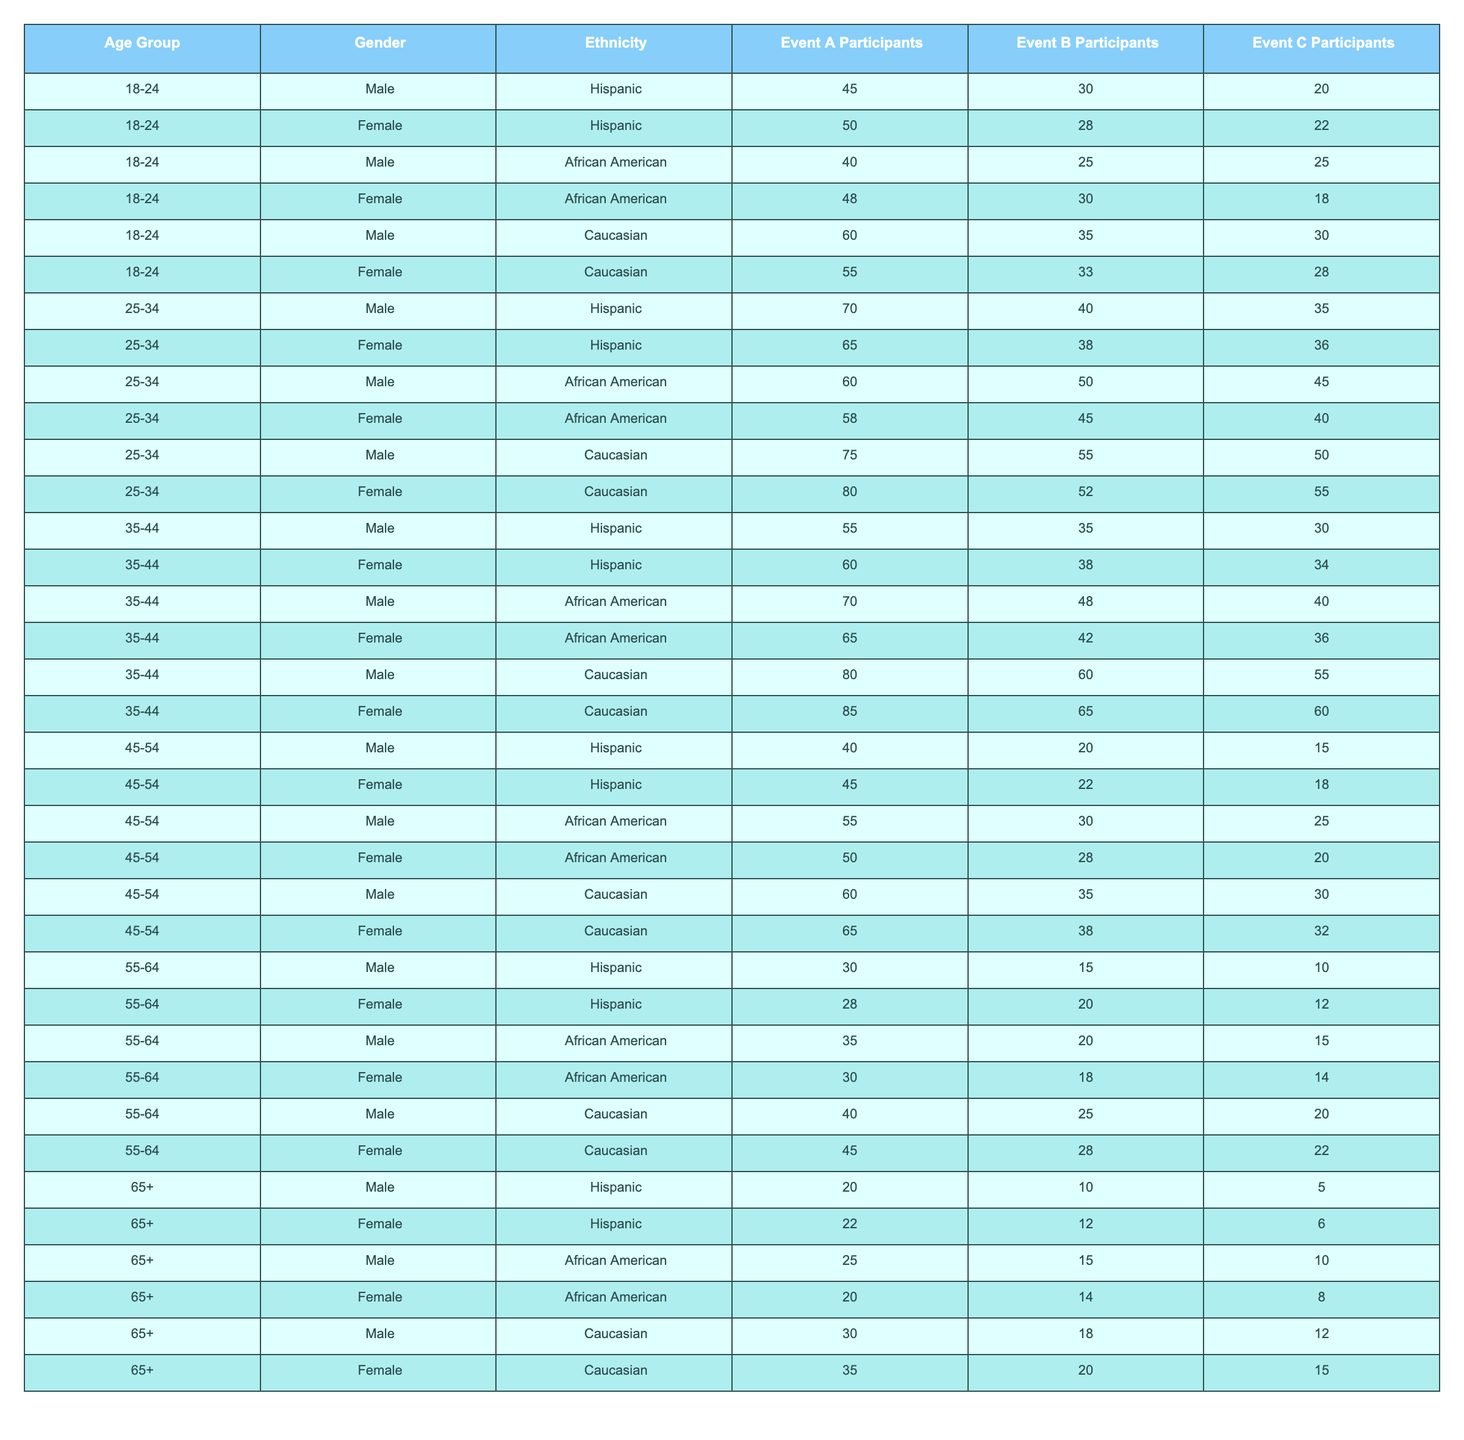What is the total number of participants in Event A from the age group 25-34? To find the total participants in Event A for the age group 25-34, add the participants across all ethnicities: 70 (Hispanic) + 65 (Hispanic) + 60 (African American) + 58 (African American) + 75 (Caucasian) + 80 (Caucasian) = 408.
Answer: 408 How many participants did Female Caucasians have in Event C? The table shows that Female Caucasians in Event C had 55 participants.
Answer: 55 Which age group had the highest number of Male African American participants in Event B? Checking the data for Male African American participants in Event B, the age group 25-34 has 50 participants, which is higher than the other age groups: 25 (18-24), 48 (35-44), 30 (45-54), 20 (55-64), and 15 (65+).
Answer: 25-34 Is there any age group where Hispanic Females had more participants in Event C than Hispanic Males? For the age group 18-24, Hispanic Females had 22 participants in Event C, while Hispanic Males had only 20, making it true that Hispanic Females had more participants in this age group.
Answer: Yes What is the average number of participants in Event A across all age groups for Female Caucasians? The Female Caucasian participants in Event A across the age groups are: 55 (18-24) + 80 (25-34) + 85 (35-44) + 65 (45-54) + 45 (55-64) + 35 (65+). That’s a total of 55 + 80 + 85 + 65 + 45 + 35 = 365. There are 6 data points, so the average is 365/6 = 60.83.
Answer: 60.83 How does the total number of Male participants in Event A compare to the total number of Female participants in the same event? First, sum the Male participants in Event A: 45 + 50 + 40 + 48 + 60 + 55 + 70 + 65 + 55 + 60 + 30 + 20 = 615. Now, sum the Female participants: 30 + 28 + 25 + 30 + 35 + 33 + 40 + 38 + 48 + 28 + 15 + 10 = 446. Therefore, Male participants exceed Female participants by 615 - 446 = 169.
Answer: Males exceed Females by 169 What percentage of participants in Event B were Male from the age group 35-44? Check the number of Male participants in Event B for age group 35-44, which is 48. The total participants for that group (Male and Female) is 48 + 42 = 90. To calculate the percentage: (48/90) * 100 = 53.33%.
Answer: 53.33% Which ethnicity had the lowest participation in Event C across all age groups? The lowest number of participants in Event C is seen among Hispanic males with 10 participants from the 55-64 age group. Evaluating all ethnicities reveals that no other ethnicity had fewer total participants in Event C.
Answer: Hispanic How many Female Hispanic participants attended Event A across all age groups? The Female Hispanic participants in Event A are: 50 (18-24) + 65 (25-34) + 60 (35-44) + 45 (45-54) + 28 (55-64) + 22 (65+) = 270.
Answer: 270 In which event did Female Caucasians have the highest participation? Checking across all events for Female Caucasians, Event B had the highest participation with 65 participants. Comparisons show: 55 (Event A), 65 (Event B), and 60 (Event C).
Answer: Event B 